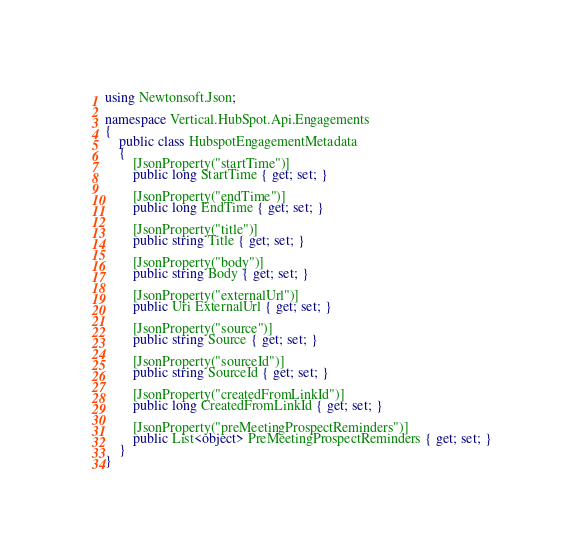Convert code to text. <code><loc_0><loc_0><loc_500><loc_500><_C#_>using Newtonsoft.Json;

namespace Vertical.HubSpot.Api.Engagements
{
    public class HubspotEngagementMetadata
    {
        [JsonProperty("startTime")]
        public long StartTime { get; set; }

        [JsonProperty("endTime")]
        public long EndTime { get; set; }

        [JsonProperty("title")]
        public string Title { get; set; }

        [JsonProperty("body")]
        public string Body { get; set; }

        [JsonProperty("externalUrl")]
        public Uri ExternalUrl { get; set; }

        [JsonProperty("source")]
        public string Source { get; set; }

        [JsonProperty("sourceId")]
        public string SourceId { get; set; }

        [JsonProperty("createdFromLinkId")]
        public long CreatedFromLinkId { get; set; }

        [JsonProperty("preMeetingProspectReminders")]
        public List<object> PreMeetingProspectReminders { get; set; }
    }
}</code> 